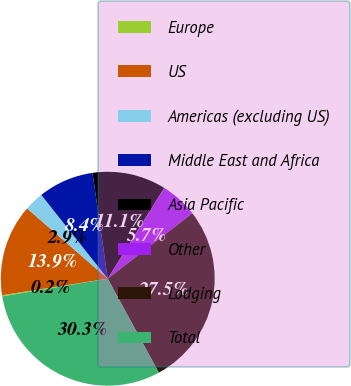<chart> <loc_0><loc_0><loc_500><loc_500><pie_chart><fcel>Europe<fcel>US<fcel>Americas (excluding US)<fcel>Middle East and Africa<fcel>Asia Pacific<fcel>Other<fcel>Lodging<fcel>Total<nl><fcel>0.19%<fcel>13.87%<fcel>2.92%<fcel>8.4%<fcel>11.13%<fcel>5.66%<fcel>27.55%<fcel>30.28%<nl></chart> 